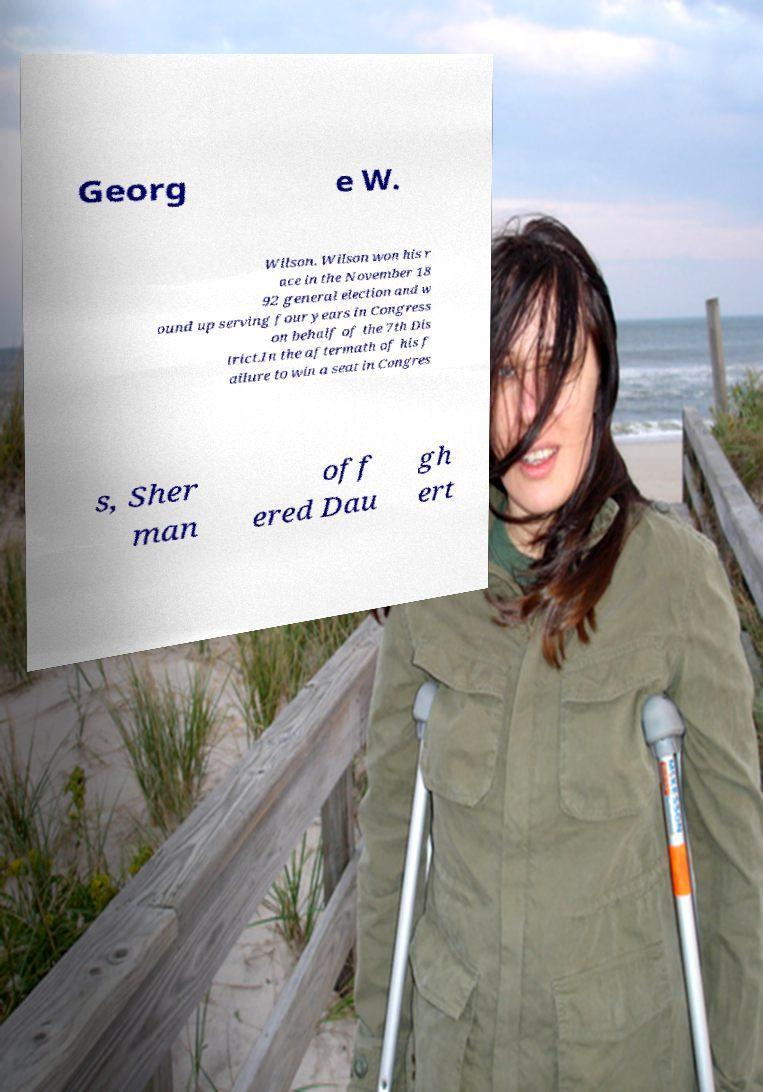Please identify and transcribe the text found in this image. Georg e W. Wilson. Wilson won his r ace in the November 18 92 general election and w ound up serving four years in Congress on behalf of the 7th Dis trict.In the aftermath of his f ailure to win a seat in Congres s, Sher man off ered Dau gh ert 